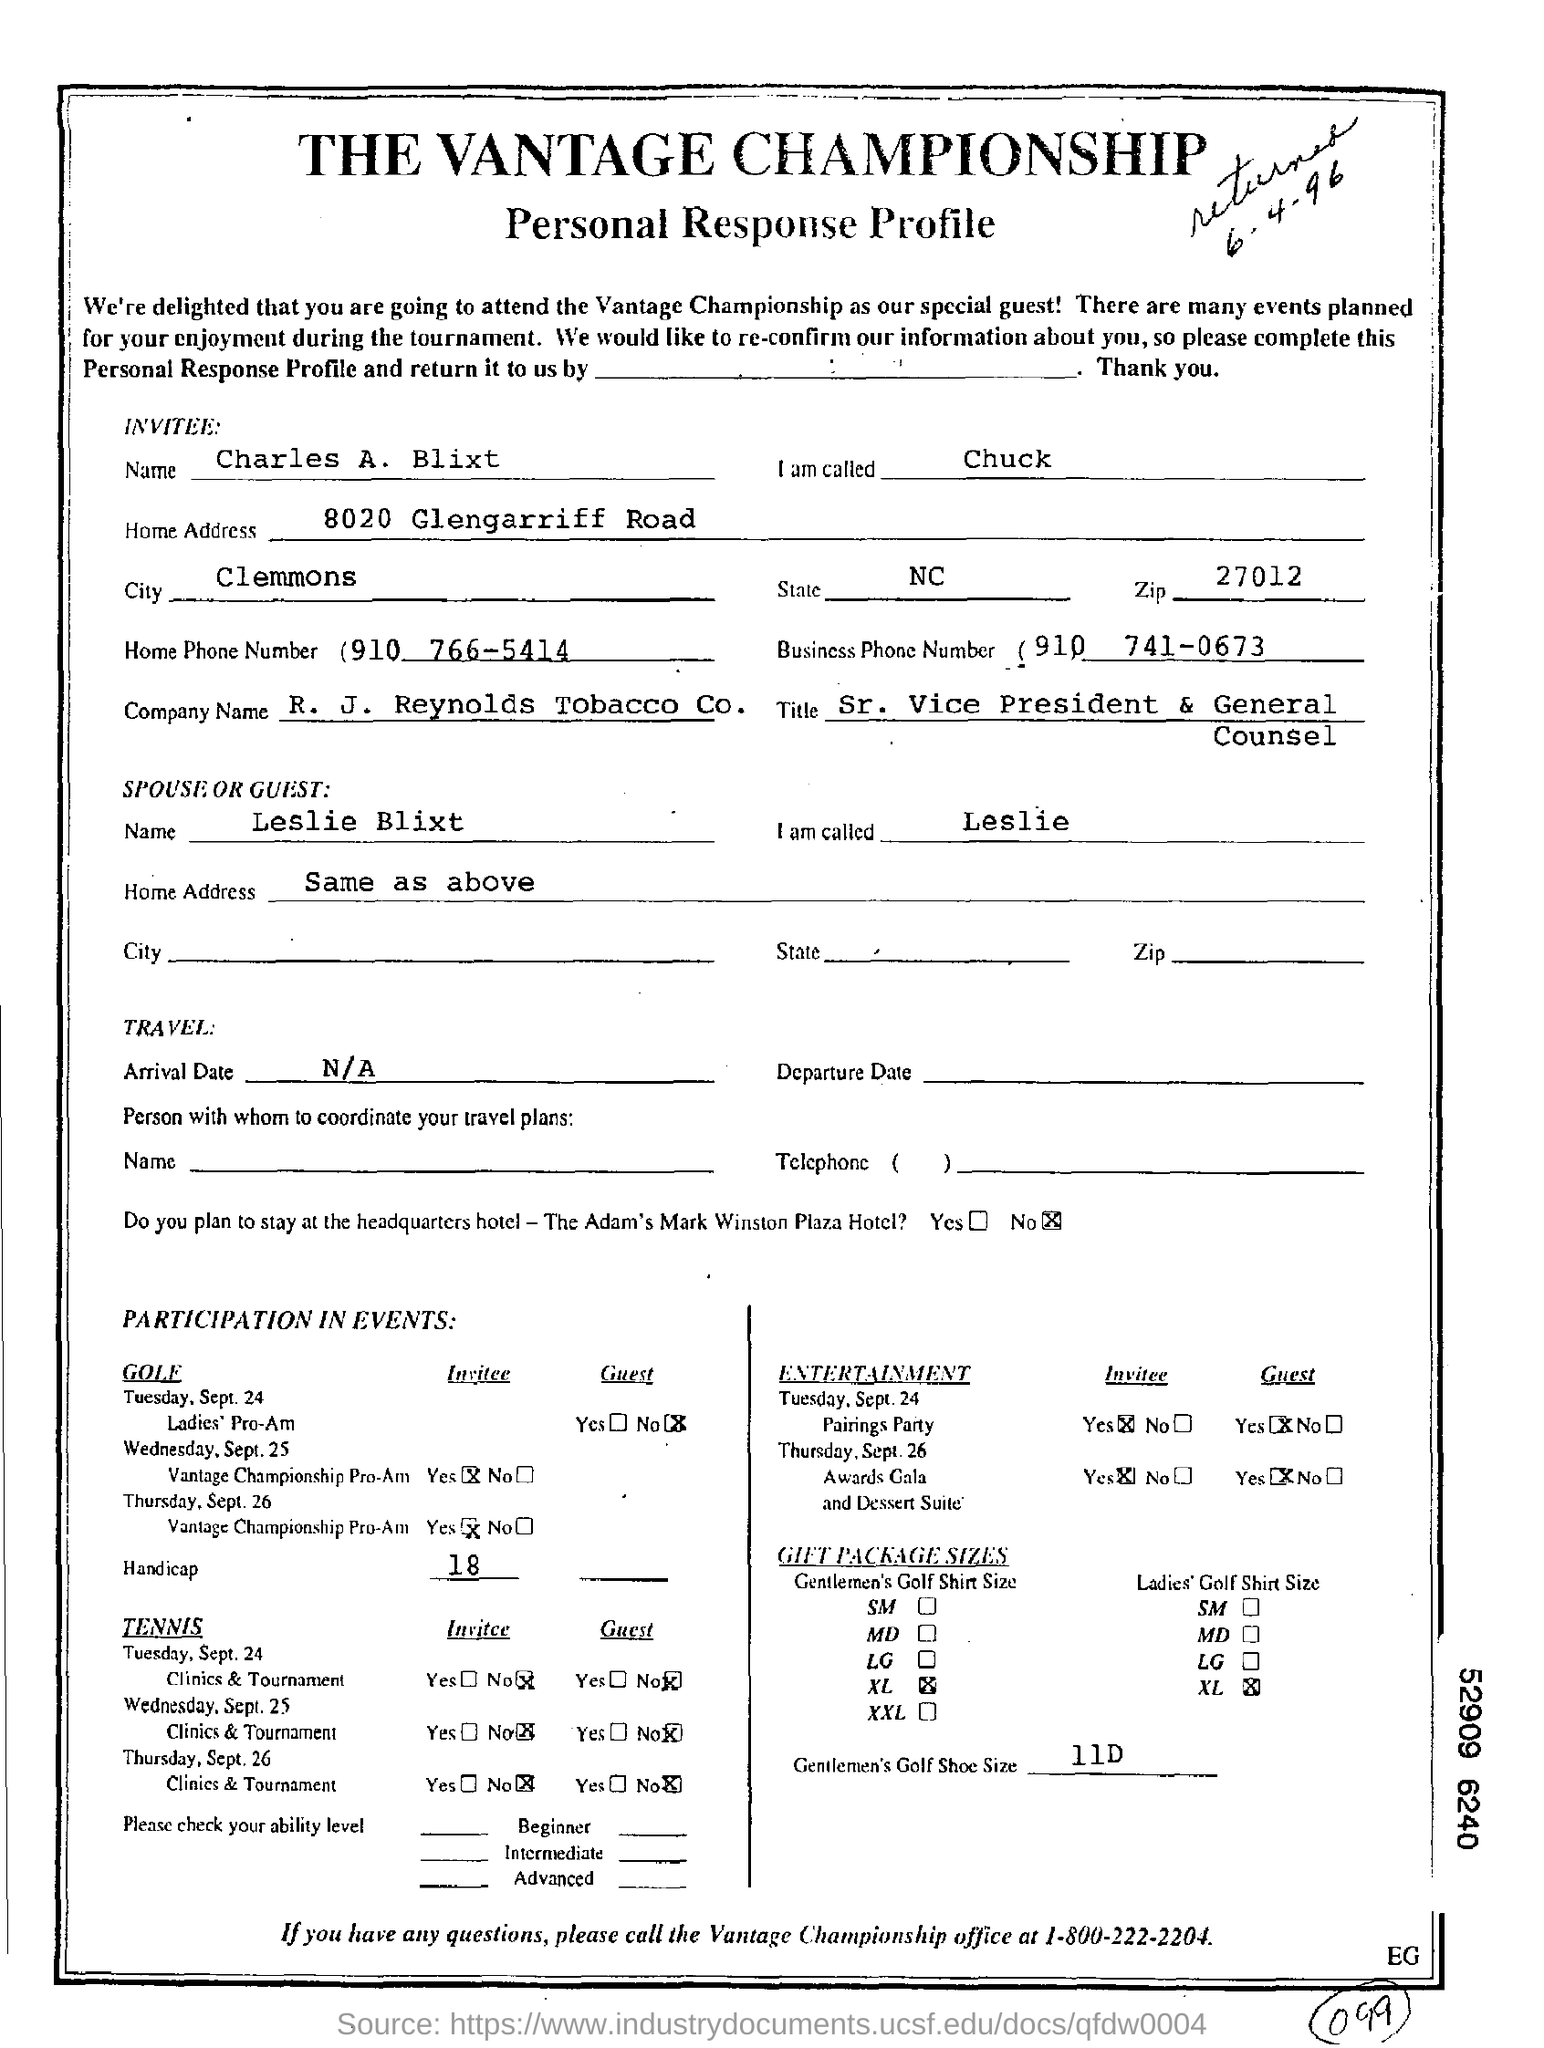Indicate a few pertinent items in this graphic. Charles A. Blixt holds the job title of Senior Vice President and General Counsel. Charles A. Blixt works for R.J. Reynolds Tobacco Company. Charles A. Blixt belongs to Clemmons in the city. I would like to confirm the zip code mentioned in the profile as 27012. The personal response profile of Charles A. Blixt is given in the provided text. 